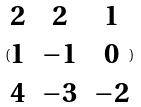<formula> <loc_0><loc_0><loc_500><loc_500>( \begin{matrix} 2 & 2 & 1 \\ 1 & - 1 & 0 \\ 4 & - 3 & - 2 \end{matrix} )</formula> 